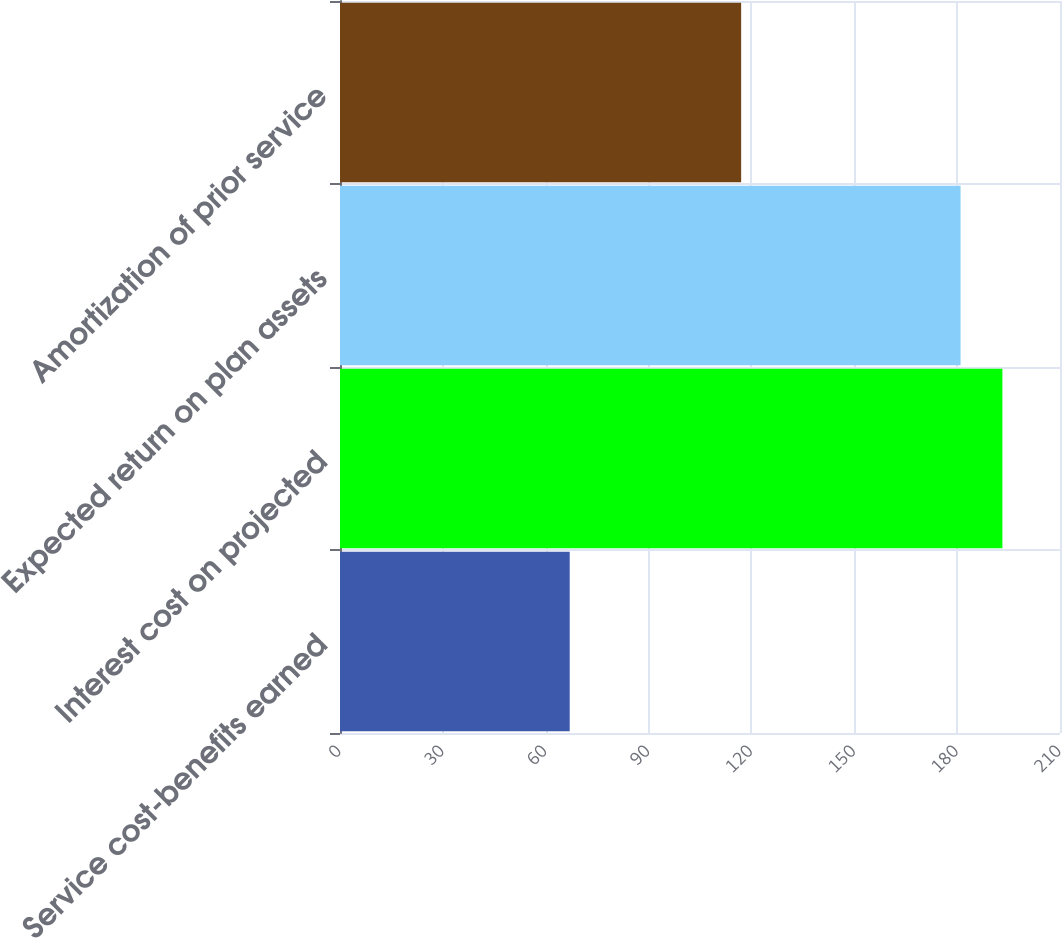Convert chart to OTSL. <chart><loc_0><loc_0><loc_500><loc_500><bar_chart><fcel>Service cost-benefits earned<fcel>Interest cost on projected<fcel>Expected return on plan assets<fcel>Amortization of prior service<nl><fcel>67<fcel>193.2<fcel>181<fcel>117<nl></chart> 